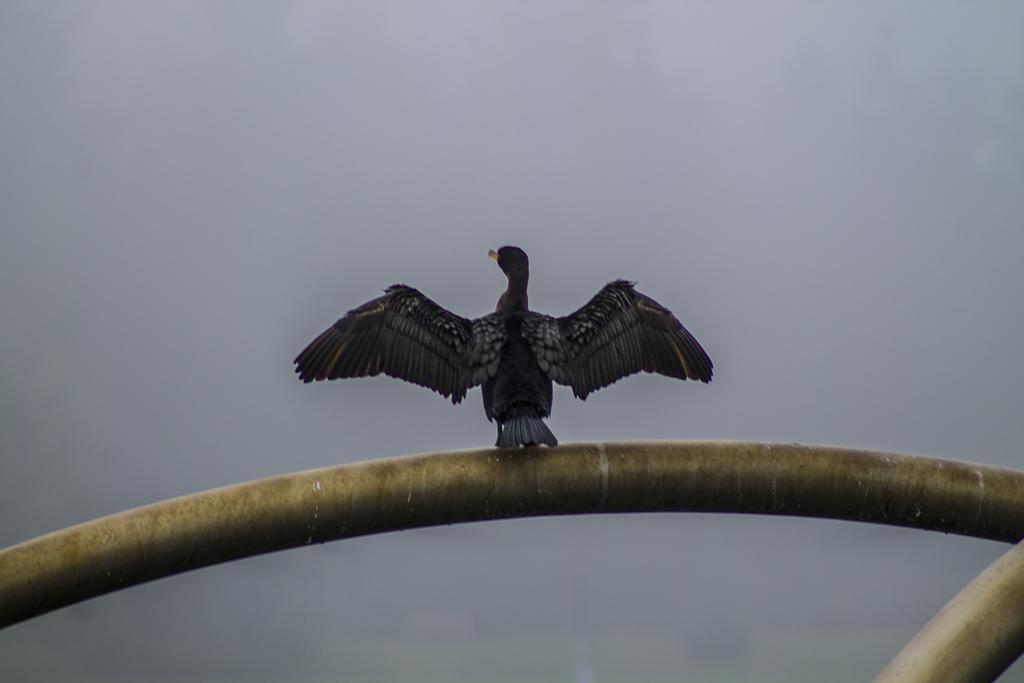Describe this image in one or two sentences. In this picture we can observe a bird which is in black color, on the railing which is in gold color. In the background there is a sky. 